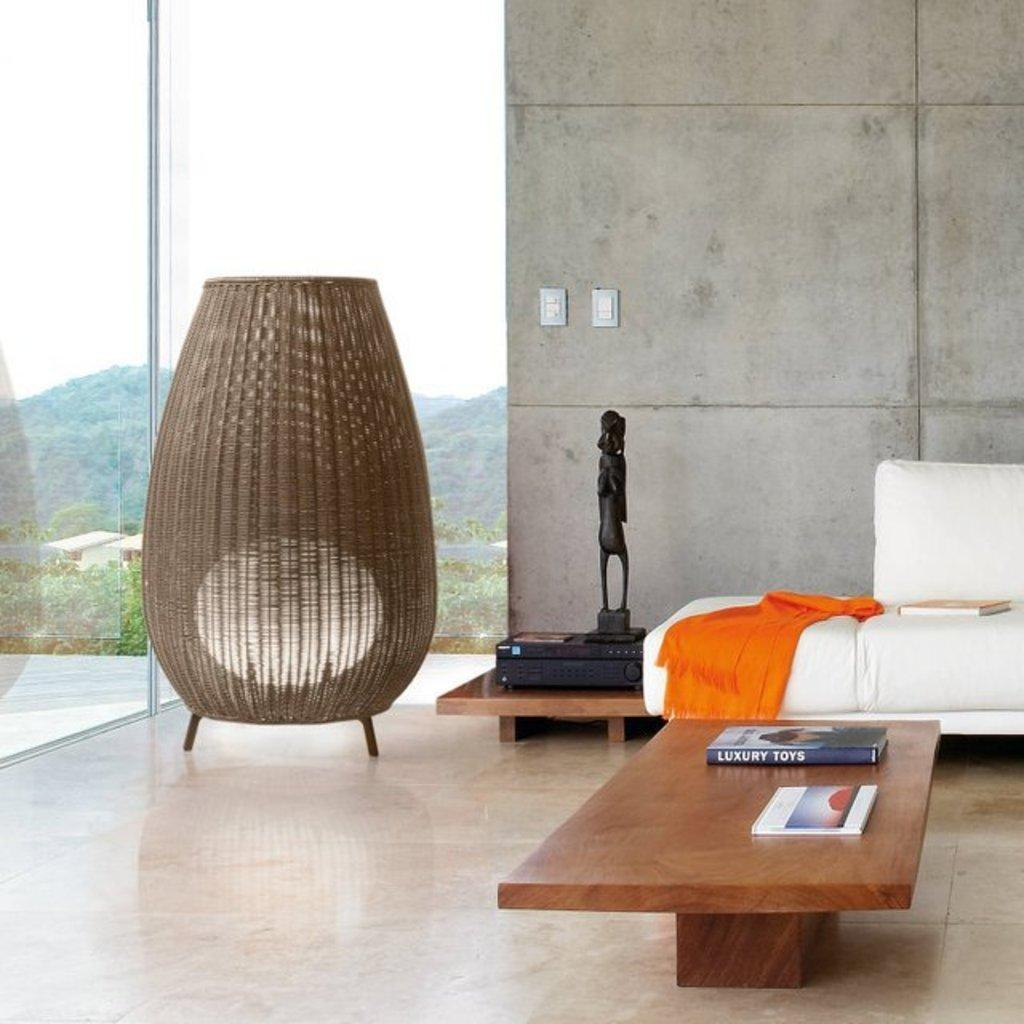What piece of furniture is present in the image? There is a table in the image. What items can be seen on the table? There are books on the table. What other piece of furniture is in the image? There is a sofa in the image. What is covering the sofa? There is a cloth on the sofa. Are there any books on the sofa? Yes, there is a book on the sofa. What type of wine is being served on the table in the image? There is no wine present in the image; it only features a table with books on it and a sofa with a cloth and a book. 